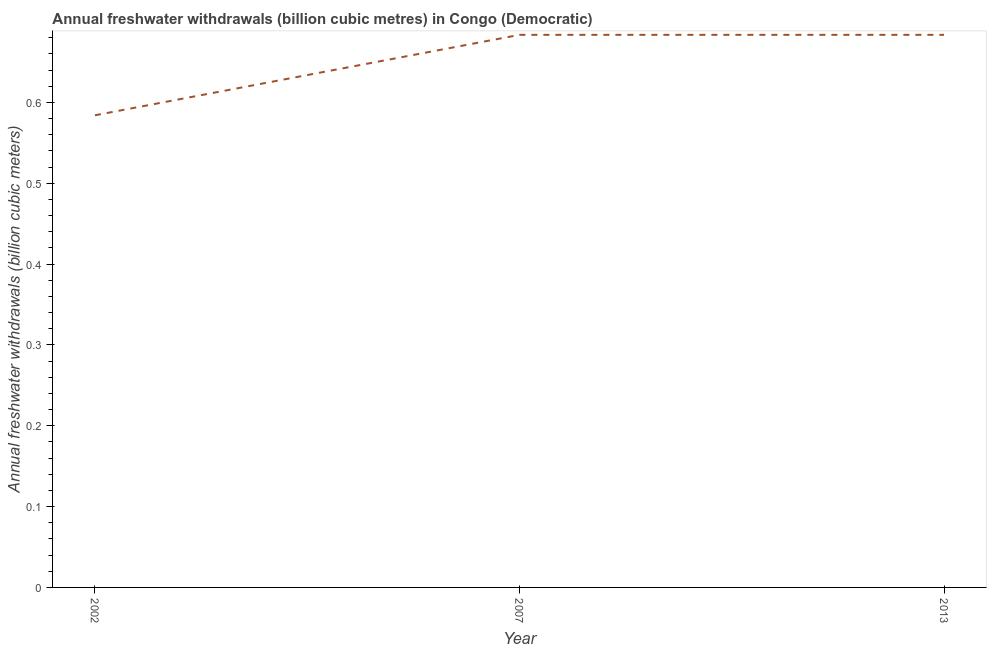What is the annual freshwater withdrawals in 2002?
Offer a very short reply. 0.58. Across all years, what is the maximum annual freshwater withdrawals?
Provide a short and direct response. 0.68. Across all years, what is the minimum annual freshwater withdrawals?
Your answer should be compact. 0.58. In which year was the annual freshwater withdrawals maximum?
Provide a short and direct response. 2007. What is the sum of the annual freshwater withdrawals?
Your answer should be compact. 1.95. What is the difference between the annual freshwater withdrawals in 2002 and 2013?
Provide a short and direct response. -0.1. What is the average annual freshwater withdrawals per year?
Make the answer very short. 0.65. What is the median annual freshwater withdrawals?
Your response must be concise. 0.68. In how many years, is the annual freshwater withdrawals greater than 0.54 billion cubic meters?
Offer a terse response. 3. What is the difference between the highest and the second highest annual freshwater withdrawals?
Keep it short and to the point. 0. What is the difference between the highest and the lowest annual freshwater withdrawals?
Make the answer very short. 0.1. Does the annual freshwater withdrawals monotonically increase over the years?
Give a very brief answer. No. How many years are there in the graph?
Give a very brief answer. 3. What is the difference between two consecutive major ticks on the Y-axis?
Give a very brief answer. 0.1. What is the title of the graph?
Give a very brief answer. Annual freshwater withdrawals (billion cubic metres) in Congo (Democratic). What is the label or title of the X-axis?
Offer a terse response. Year. What is the label or title of the Y-axis?
Make the answer very short. Annual freshwater withdrawals (billion cubic meters). What is the Annual freshwater withdrawals (billion cubic meters) of 2002?
Provide a succinct answer. 0.58. What is the Annual freshwater withdrawals (billion cubic meters) in 2007?
Keep it short and to the point. 0.68. What is the Annual freshwater withdrawals (billion cubic meters) in 2013?
Make the answer very short. 0.68. What is the difference between the Annual freshwater withdrawals (billion cubic meters) in 2002 and 2007?
Your answer should be very brief. -0.1. What is the difference between the Annual freshwater withdrawals (billion cubic meters) in 2002 and 2013?
Offer a terse response. -0.1. What is the difference between the Annual freshwater withdrawals (billion cubic meters) in 2007 and 2013?
Your answer should be compact. 0. What is the ratio of the Annual freshwater withdrawals (billion cubic meters) in 2002 to that in 2007?
Your response must be concise. 0.85. What is the ratio of the Annual freshwater withdrawals (billion cubic meters) in 2002 to that in 2013?
Your answer should be very brief. 0.85. What is the ratio of the Annual freshwater withdrawals (billion cubic meters) in 2007 to that in 2013?
Your answer should be compact. 1. 